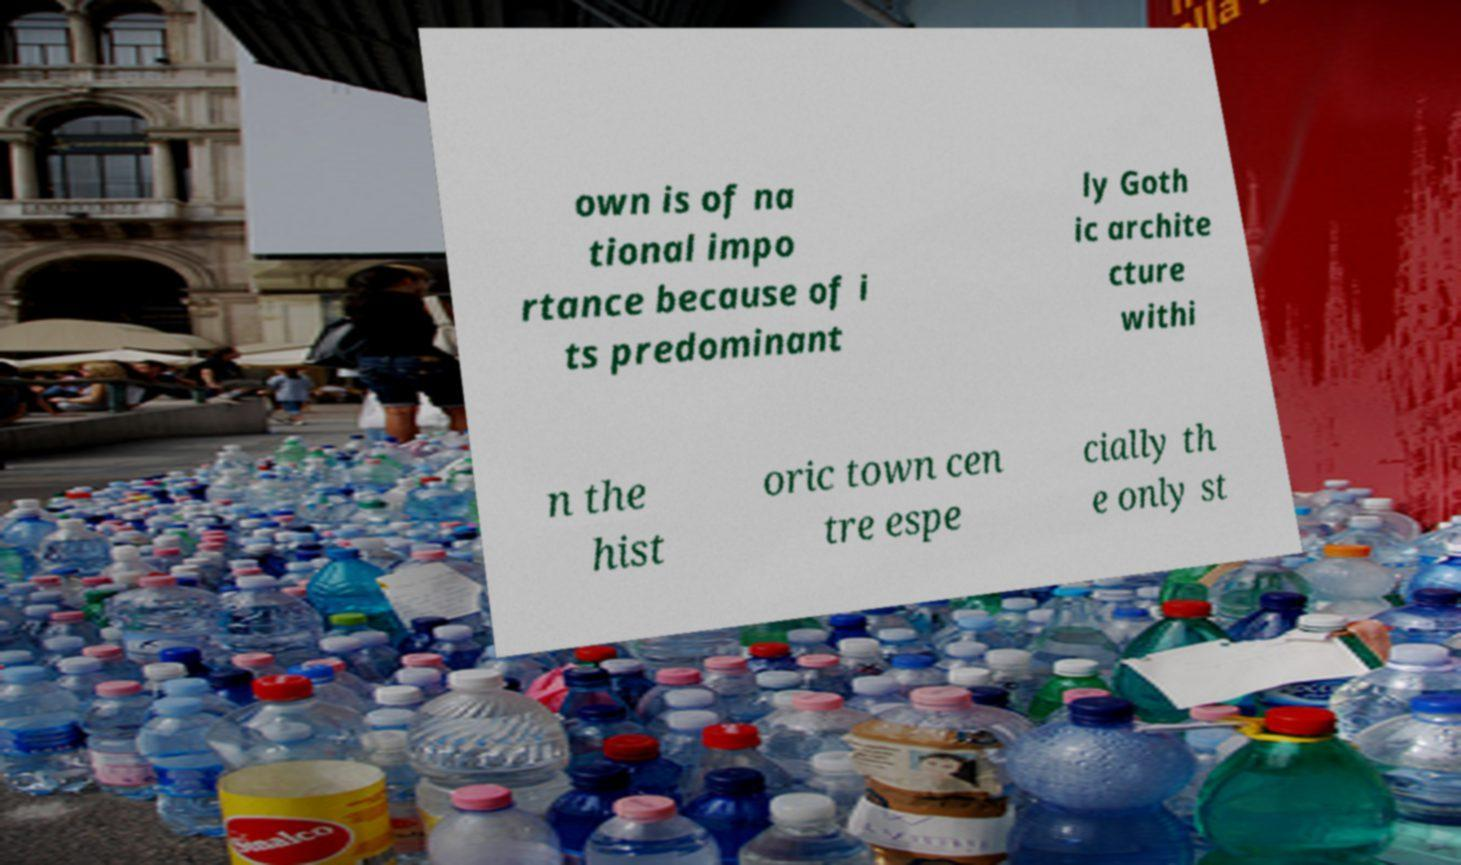Please identify and transcribe the text found in this image. own is of na tional impo rtance because of i ts predominant ly Goth ic archite cture withi n the hist oric town cen tre espe cially th e only st 